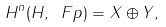Convert formula to latex. <formula><loc_0><loc_0><loc_500><loc_500>H ^ { n } ( H , \ F p ) = X \oplus Y ,</formula> 